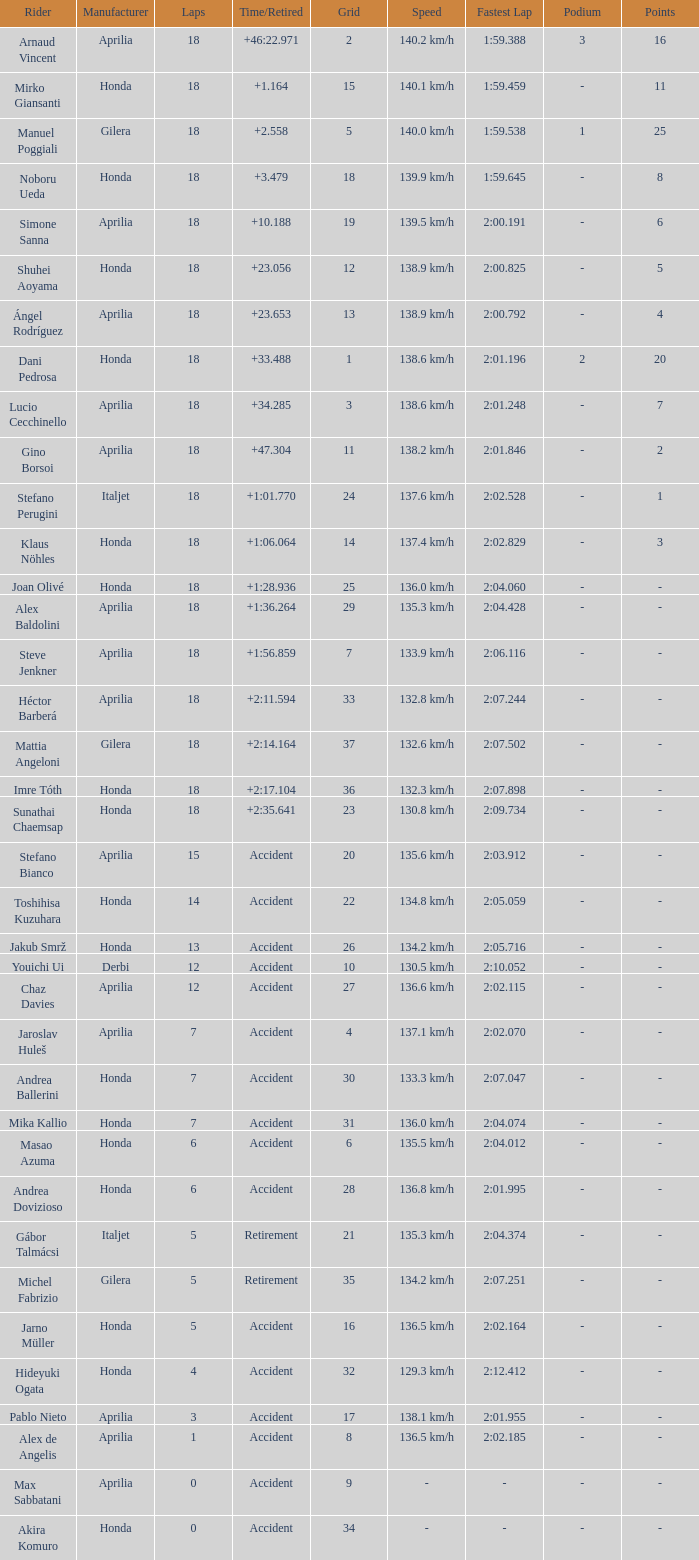Who is the rider with less than 15 laps, more than 32 grids, and an accident time/retired? Akira Komuro. 